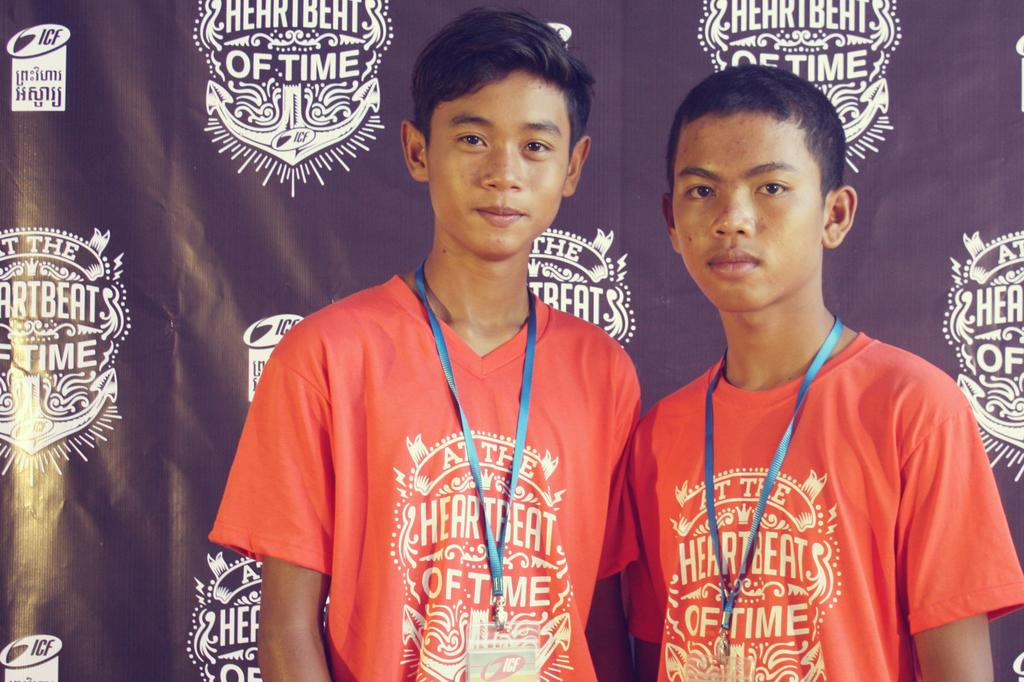<image>
Present a compact description of the photo's key features. heartbeats of time written on the back board with two boys wearing shirts that say the same 